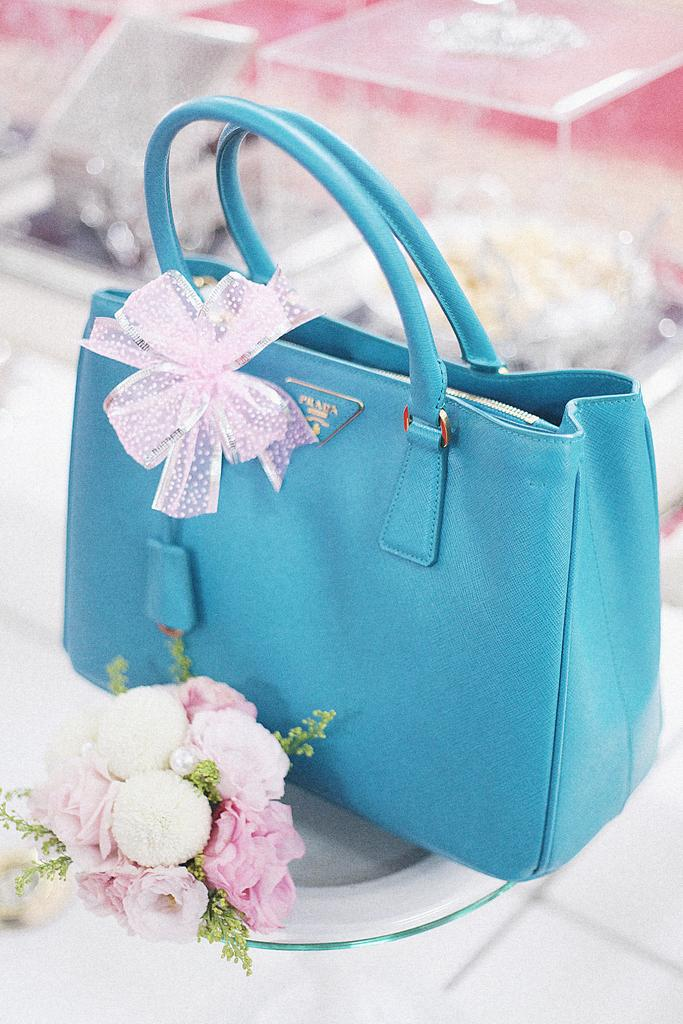What type of object can be seen in the image? There is a bag in the image. What else is present on the table in the image? There are flowers and boxes on the table in the image. Can you describe the arrangement of the objects on the table? All of these objects, including the bag, flowers, and boxes, are on a table. How many giraffes are visible in the image? There are no giraffes present in the image. What type of cart is being used to transport the flowers in the image? There is no cart present in the image; the flowers are on a table. 